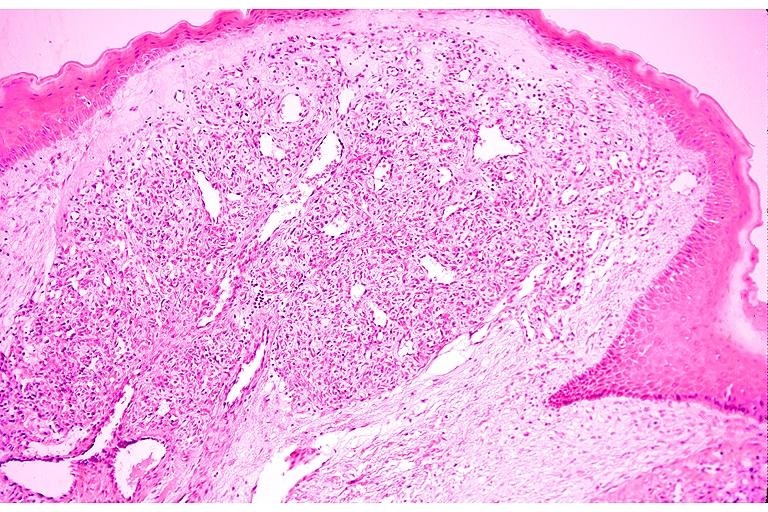what is present?
Answer the question using a single word or phrase. Oral 